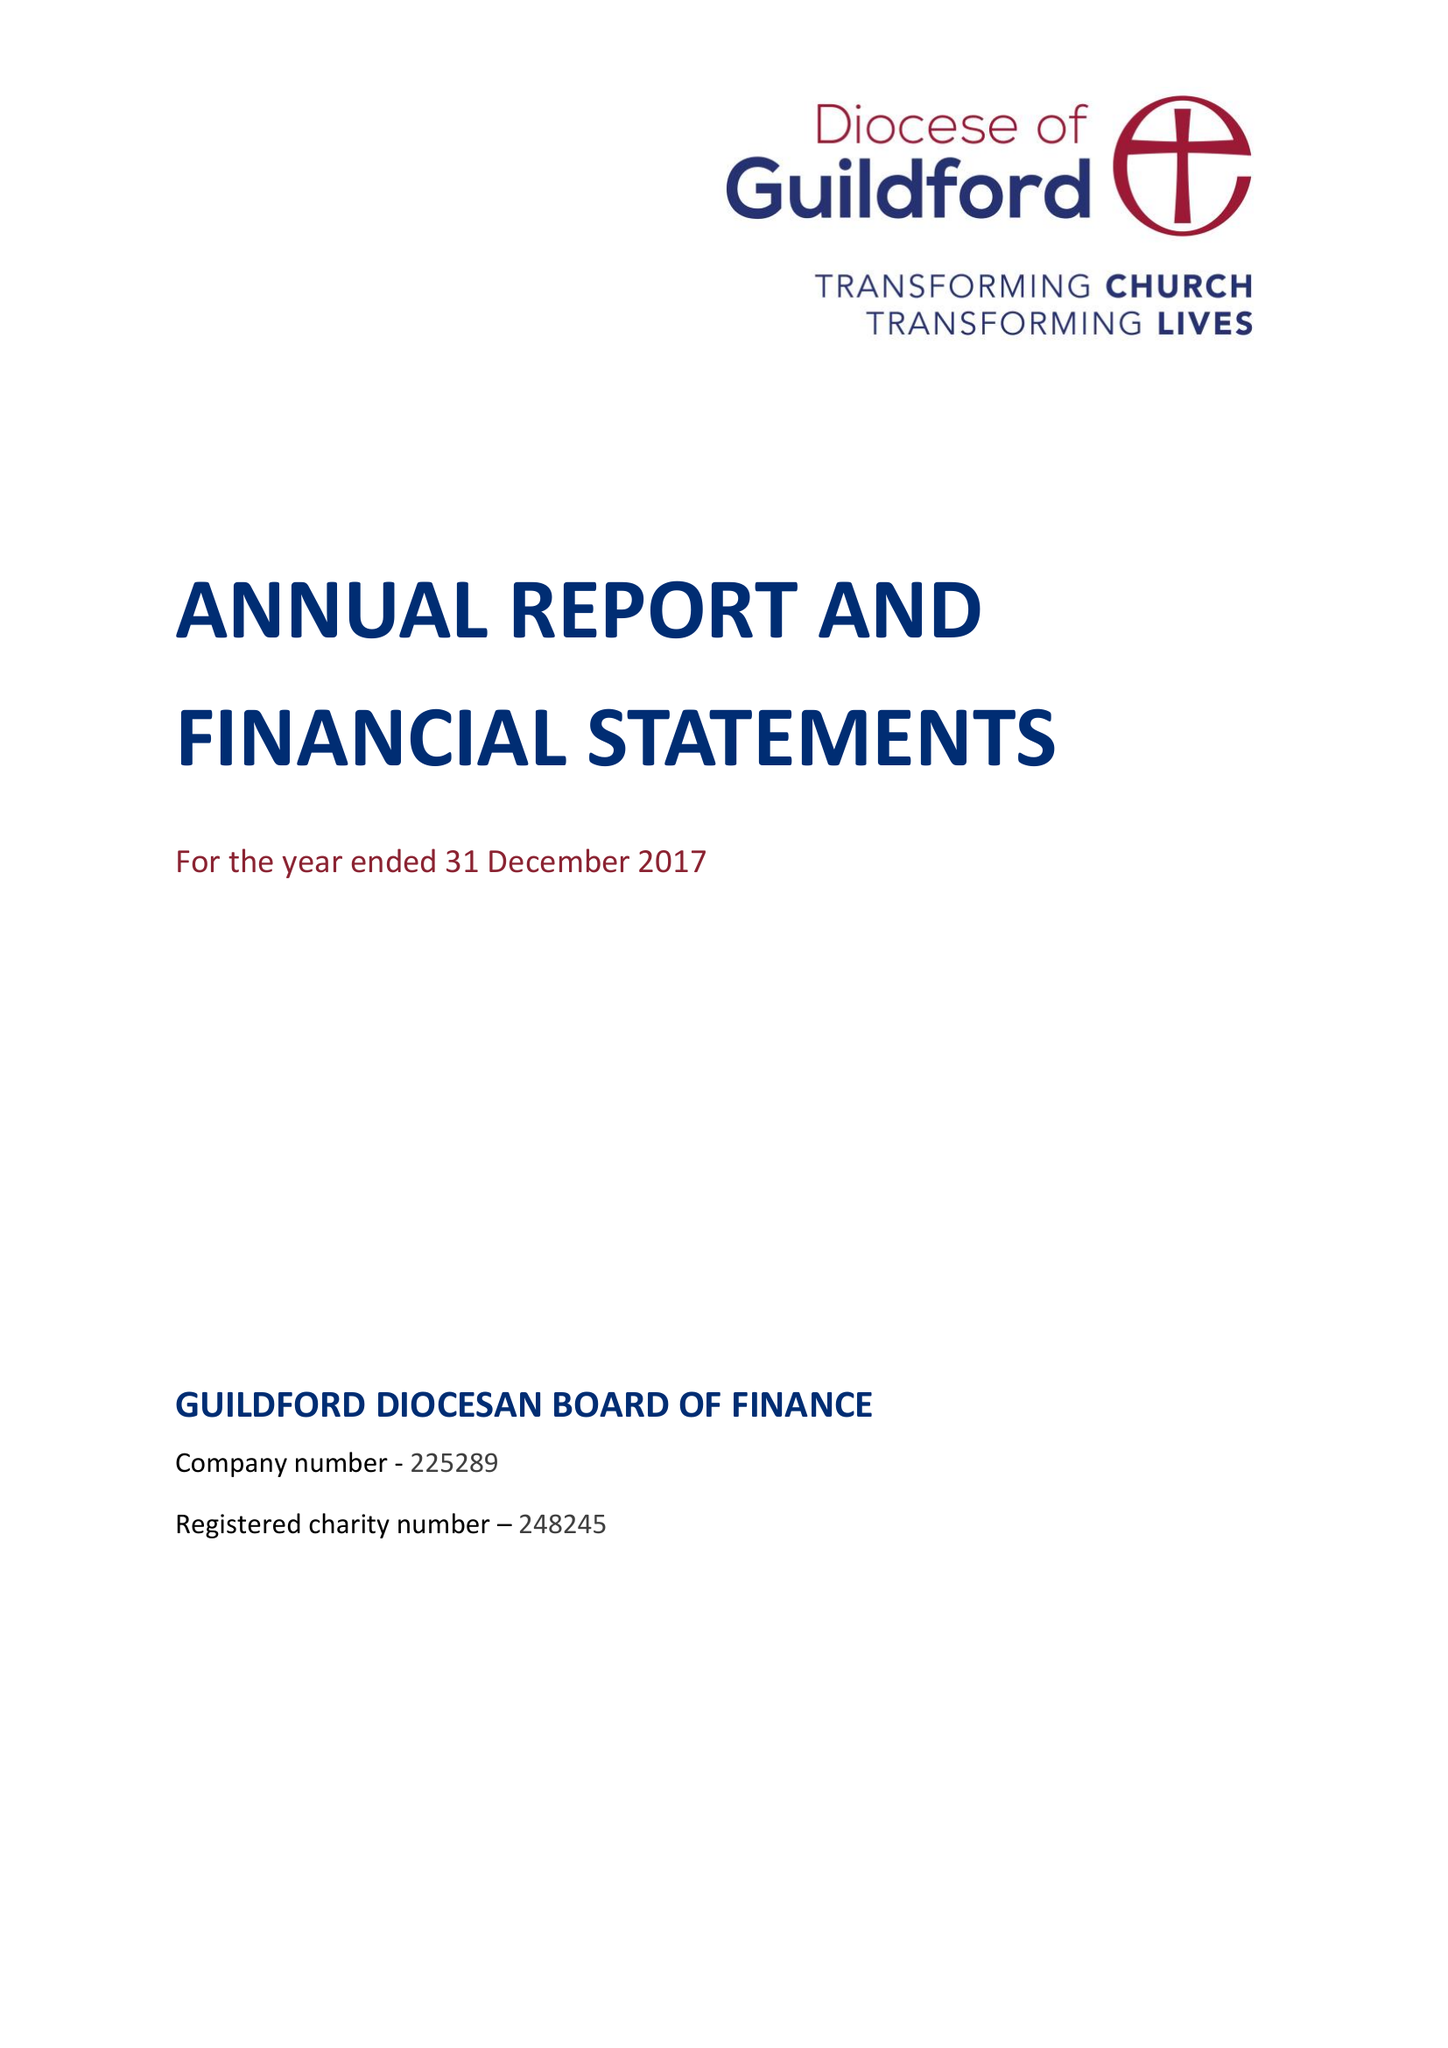What is the value for the report_date?
Answer the question using a single word or phrase. 2017-12-31 